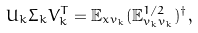<formula> <loc_0><loc_0><loc_500><loc_500>U _ { k } \Sigma _ { k } V ^ { T } _ { k } = { \mathbb { E } } _ { x v _ { k } } ( { \mathbb { E } } ^ { 1 / 2 } _ { v _ { k } v _ { k } } ) ^ { \dag } ,</formula> 